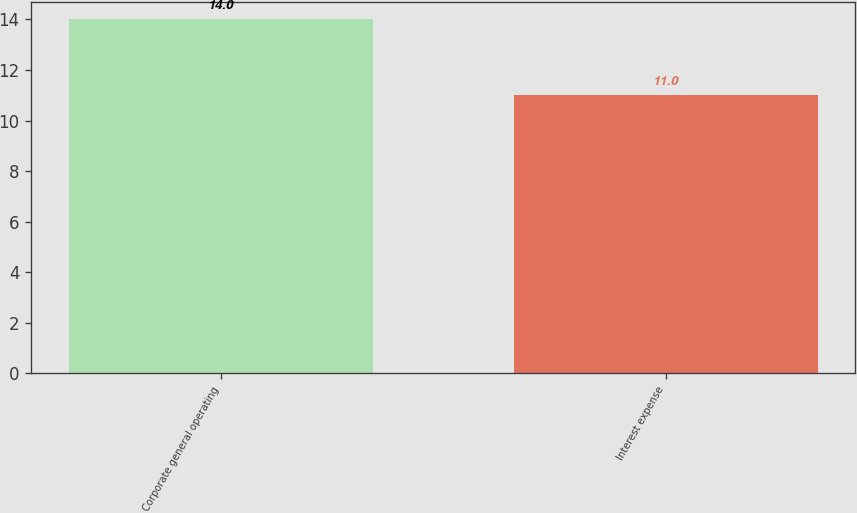<chart> <loc_0><loc_0><loc_500><loc_500><bar_chart><fcel>Corporate general operating<fcel>Interest expense<nl><fcel>14<fcel>11<nl></chart> 